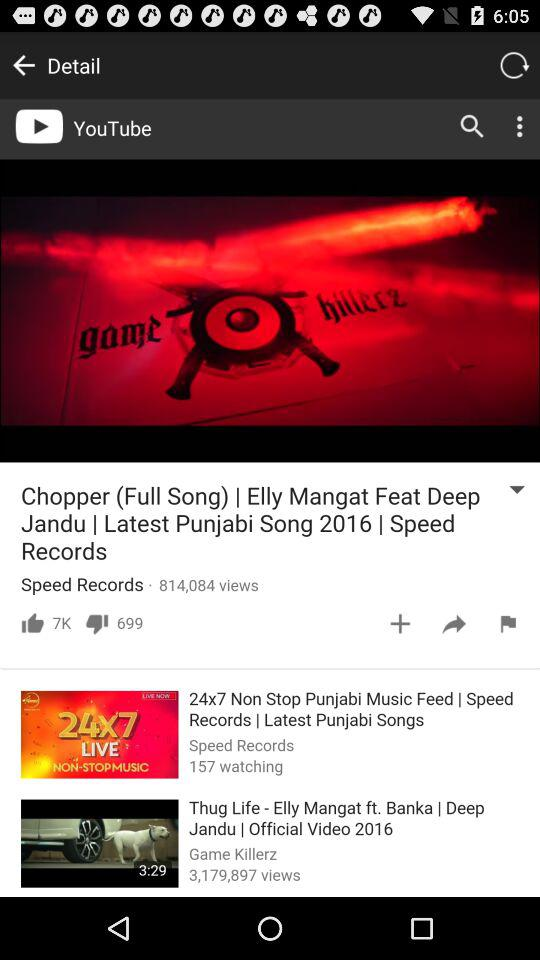How many more views does the video with the most views have than the video with the least views?
Answer the question using a single word or phrase. 2365813 